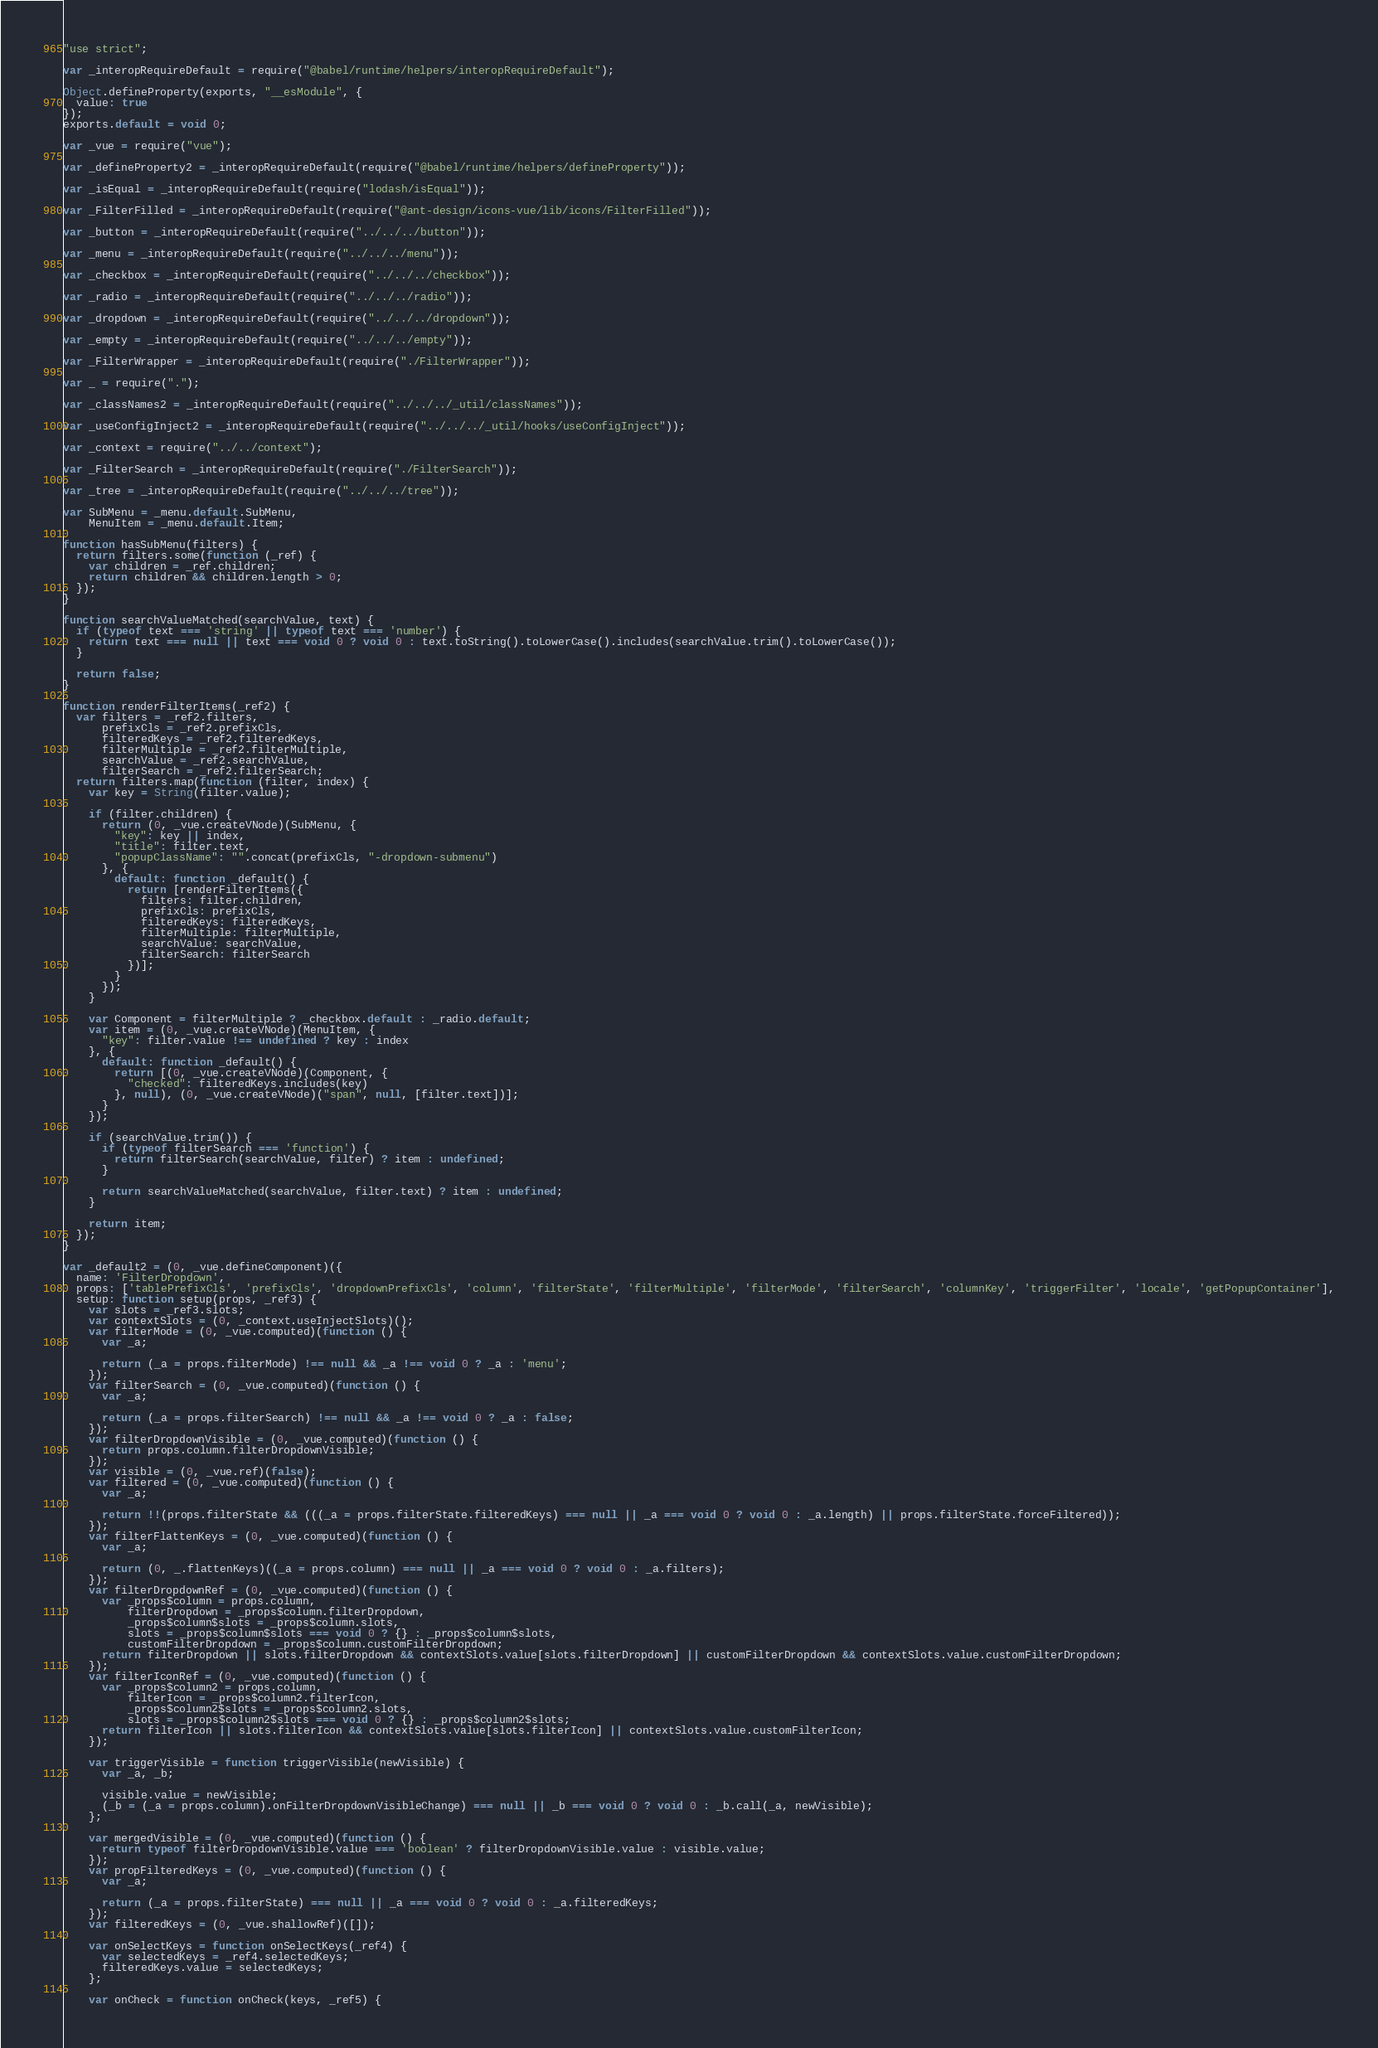<code> <loc_0><loc_0><loc_500><loc_500><_JavaScript_>"use strict";

var _interopRequireDefault = require("@babel/runtime/helpers/interopRequireDefault");

Object.defineProperty(exports, "__esModule", {
  value: true
});
exports.default = void 0;

var _vue = require("vue");

var _defineProperty2 = _interopRequireDefault(require("@babel/runtime/helpers/defineProperty"));

var _isEqual = _interopRequireDefault(require("lodash/isEqual"));

var _FilterFilled = _interopRequireDefault(require("@ant-design/icons-vue/lib/icons/FilterFilled"));

var _button = _interopRequireDefault(require("../../../button"));

var _menu = _interopRequireDefault(require("../../../menu"));

var _checkbox = _interopRequireDefault(require("../../../checkbox"));

var _radio = _interopRequireDefault(require("../../../radio"));

var _dropdown = _interopRequireDefault(require("../../../dropdown"));

var _empty = _interopRequireDefault(require("../../../empty"));

var _FilterWrapper = _interopRequireDefault(require("./FilterWrapper"));

var _ = require(".");

var _classNames2 = _interopRequireDefault(require("../../../_util/classNames"));

var _useConfigInject2 = _interopRequireDefault(require("../../../_util/hooks/useConfigInject"));

var _context = require("../../context");

var _FilterSearch = _interopRequireDefault(require("./FilterSearch"));

var _tree = _interopRequireDefault(require("../../../tree"));

var SubMenu = _menu.default.SubMenu,
    MenuItem = _menu.default.Item;

function hasSubMenu(filters) {
  return filters.some(function (_ref) {
    var children = _ref.children;
    return children && children.length > 0;
  });
}

function searchValueMatched(searchValue, text) {
  if (typeof text === 'string' || typeof text === 'number') {
    return text === null || text === void 0 ? void 0 : text.toString().toLowerCase().includes(searchValue.trim().toLowerCase());
  }

  return false;
}

function renderFilterItems(_ref2) {
  var filters = _ref2.filters,
      prefixCls = _ref2.prefixCls,
      filteredKeys = _ref2.filteredKeys,
      filterMultiple = _ref2.filterMultiple,
      searchValue = _ref2.searchValue,
      filterSearch = _ref2.filterSearch;
  return filters.map(function (filter, index) {
    var key = String(filter.value);

    if (filter.children) {
      return (0, _vue.createVNode)(SubMenu, {
        "key": key || index,
        "title": filter.text,
        "popupClassName": "".concat(prefixCls, "-dropdown-submenu")
      }, {
        default: function _default() {
          return [renderFilterItems({
            filters: filter.children,
            prefixCls: prefixCls,
            filteredKeys: filteredKeys,
            filterMultiple: filterMultiple,
            searchValue: searchValue,
            filterSearch: filterSearch
          })];
        }
      });
    }

    var Component = filterMultiple ? _checkbox.default : _radio.default;
    var item = (0, _vue.createVNode)(MenuItem, {
      "key": filter.value !== undefined ? key : index
    }, {
      default: function _default() {
        return [(0, _vue.createVNode)(Component, {
          "checked": filteredKeys.includes(key)
        }, null), (0, _vue.createVNode)("span", null, [filter.text])];
      }
    });

    if (searchValue.trim()) {
      if (typeof filterSearch === 'function') {
        return filterSearch(searchValue, filter) ? item : undefined;
      }

      return searchValueMatched(searchValue, filter.text) ? item : undefined;
    }

    return item;
  });
}

var _default2 = (0, _vue.defineComponent)({
  name: 'FilterDropdown',
  props: ['tablePrefixCls', 'prefixCls', 'dropdownPrefixCls', 'column', 'filterState', 'filterMultiple', 'filterMode', 'filterSearch', 'columnKey', 'triggerFilter', 'locale', 'getPopupContainer'],
  setup: function setup(props, _ref3) {
    var slots = _ref3.slots;
    var contextSlots = (0, _context.useInjectSlots)();
    var filterMode = (0, _vue.computed)(function () {
      var _a;

      return (_a = props.filterMode) !== null && _a !== void 0 ? _a : 'menu';
    });
    var filterSearch = (0, _vue.computed)(function () {
      var _a;

      return (_a = props.filterSearch) !== null && _a !== void 0 ? _a : false;
    });
    var filterDropdownVisible = (0, _vue.computed)(function () {
      return props.column.filterDropdownVisible;
    });
    var visible = (0, _vue.ref)(false);
    var filtered = (0, _vue.computed)(function () {
      var _a;

      return !!(props.filterState && (((_a = props.filterState.filteredKeys) === null || _a === void 0 ? void 0 : _a.length) || props.filterState.forceFiltered));
    });
    var filterFlattenKeys = (0, _vue.computed)(function () {
      var _a;

      return (0, _.flattenKeys)((_a = props.column) === null || _a === void 0 ? void 0 : _a.filters);
    });
    var filterDropdownRef = (0, _vue.computed)(function () {
      var _props$column = props.column,
          filterDropdown = _props$column.filterDropdown,
          _props$column$slots = _props$column.slots,
          slots = _props$column$slots === void 0 ? {} : _props$column$slots,
          customFilterDropdown = _props$column.customFilterDropdown;
      return filterDropdown || slots.filterDropdown && contextSlots.value[slots.filterDropdown] || customFilterDropdown && contextSlots.value.customFilterDropdown;
    });
    var filterIconRef = (0, _vue.computed)(function () {
      var _props$column2 = props.column,
          filterIcon = _props$column2.filterIcon,
          _props$column2$slots = _props$column2.slots,
          slots = _props$column2$slots === void 0 ? {} : _props$column2$slots;
      return filterIcon || slots.filterIcon && contextSlots.value[slots.filterIcon] || contextSlots.value.customFilterIcon;
    });

    var triggerVisible = function triggerVisible(newVisible) {
      var _a, _b;

      visible.value = newVisible;
      (_b = (_a = props.column).onFilterDropdownVisibleChange) === null || _b === void 0 ? void 0 : _b.call(_a, newVisible);
    };

    var mergedVisible = (0, _vue.computed)(function () {
      return typeof filterDropdownVisible.value === 'boolean' ? filterDropdownVisible.value : visible.value;
    });
    var propFilteredKeys = (0, _vue.computed)(function () {
      var _a;

      return (_a = props.filterState) === null || _a === void 0 ? void 0 : _a.filteredKeys;
    });
    var filteredKeys = (0, _vue.shallowRef)([]);

    var onSelectKeys = function onSelectKeys(_ref4) {
      var selectedKeys = _ref4.selectedKeys;
      filteredKeys.value = selectedKeys;
    };

    var onCheck = function onCheck(keys, _ref5) {</code> 